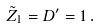Convert formula to latex. <formula><loc_0><loc_0><loc_500><loc_500>\tilde { Z } _ { 1 } = D ^ { \prime } = 1 \, .</formula> 